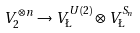<formula> <loc_0><loc_0><loc_500><loc_500>V _ { 2 } ^ { \otimes n } \to V _ { \L } ^ { U ( 2 ) } \otimes V _ { \L } ^ { S _ { n } }</formula> 